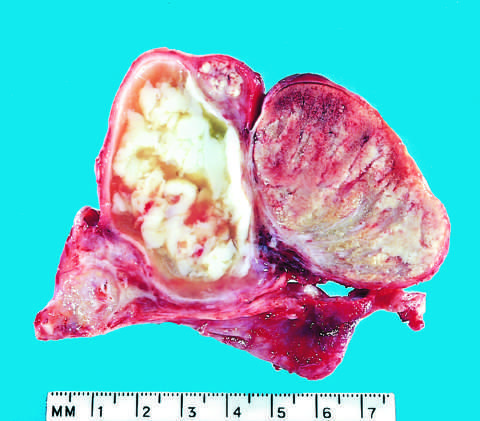what is caused by gonococcal infection?
Answer the question using a single word or phrase. Acute epididymitis 